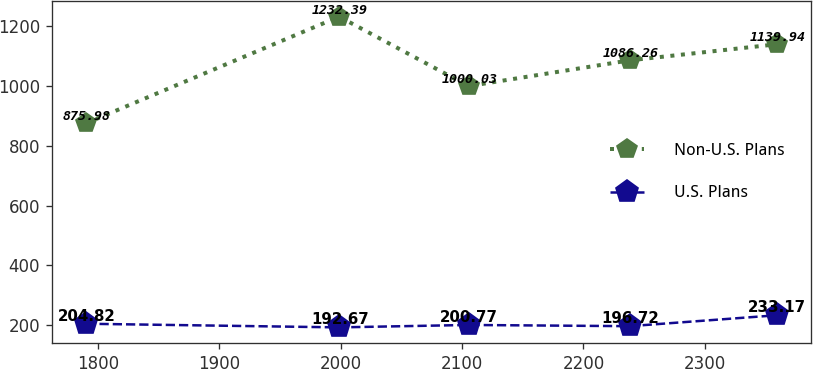<chart> <loc_0><loc_0><loc_500><loc_500><line_chart><ecel><fcel>Non-U.S. Plans<fcel>U.S. Plans<nl><fcel>1790.5<fcel>875.98<fcel>204.82<nl><fcel>1998.8<fcel>1232.39<fcel>192.67<nl><fcel>2105.3<fcel>1000.03<fcel>200.77<nl><fcel>2237.97<fcel>1086.26<fcel>196.72<nl><fcel>2358.97<fcel>1139.94<fcel>233.17<nl></chart> 